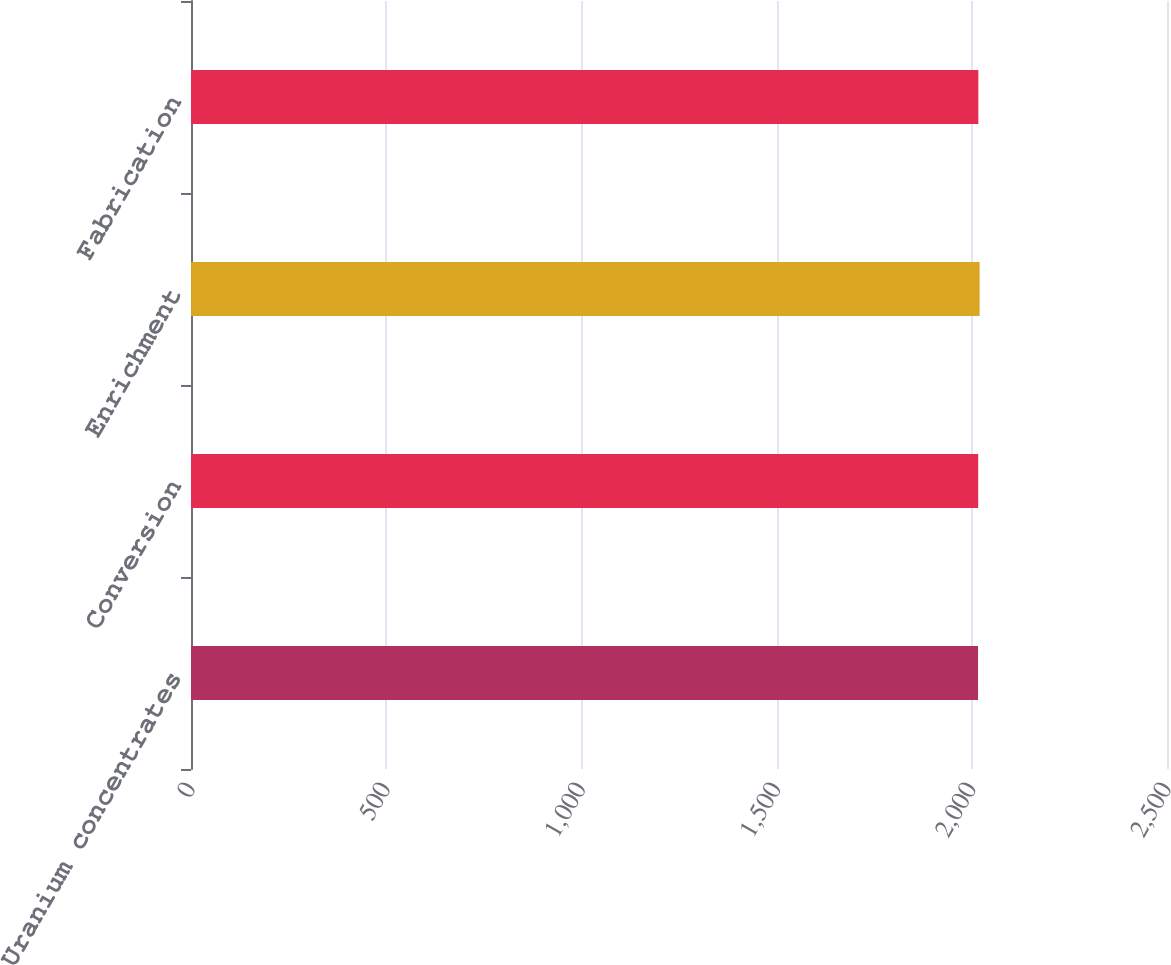<chart> <loc_0><loc_0><loc_500><loc_500><bar_chart><fcel>Uranium concentrates<fcel>Conversion<fcel>Enrichment<fcel>Fabrication<nl><fcel>2016<fcel>2016.4<fcel>2020<fcel>2016.8<nl></chart> 